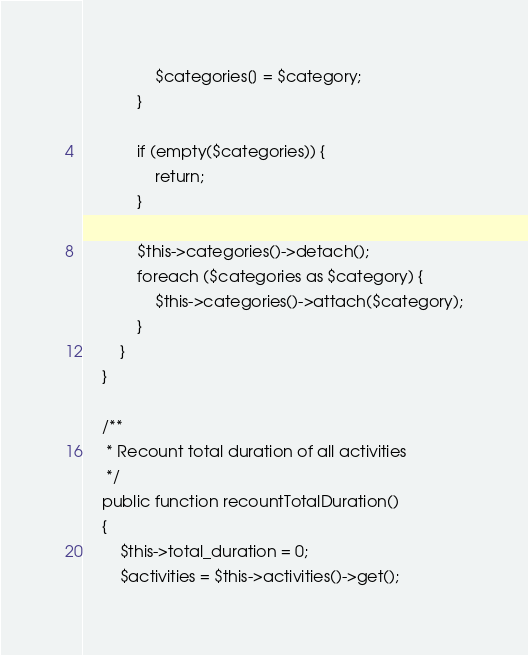<code> <loc_0><loc_0><loc_500><loc_500><_PHP_>
                $categories[] = $category;
            }

            if (empty($categories)) {
                return;
            }

            $this->categories()->detach();
            foreach ($categories as $category) {
                $this->categories()->attach($category);
            }
        }
    }

    /**
     * Recount total duration of all activities
     */
    public function recountTotalDuration()
    {
        $this->total_duration = 0;
        $activities = $this->activities()->get();</code> 